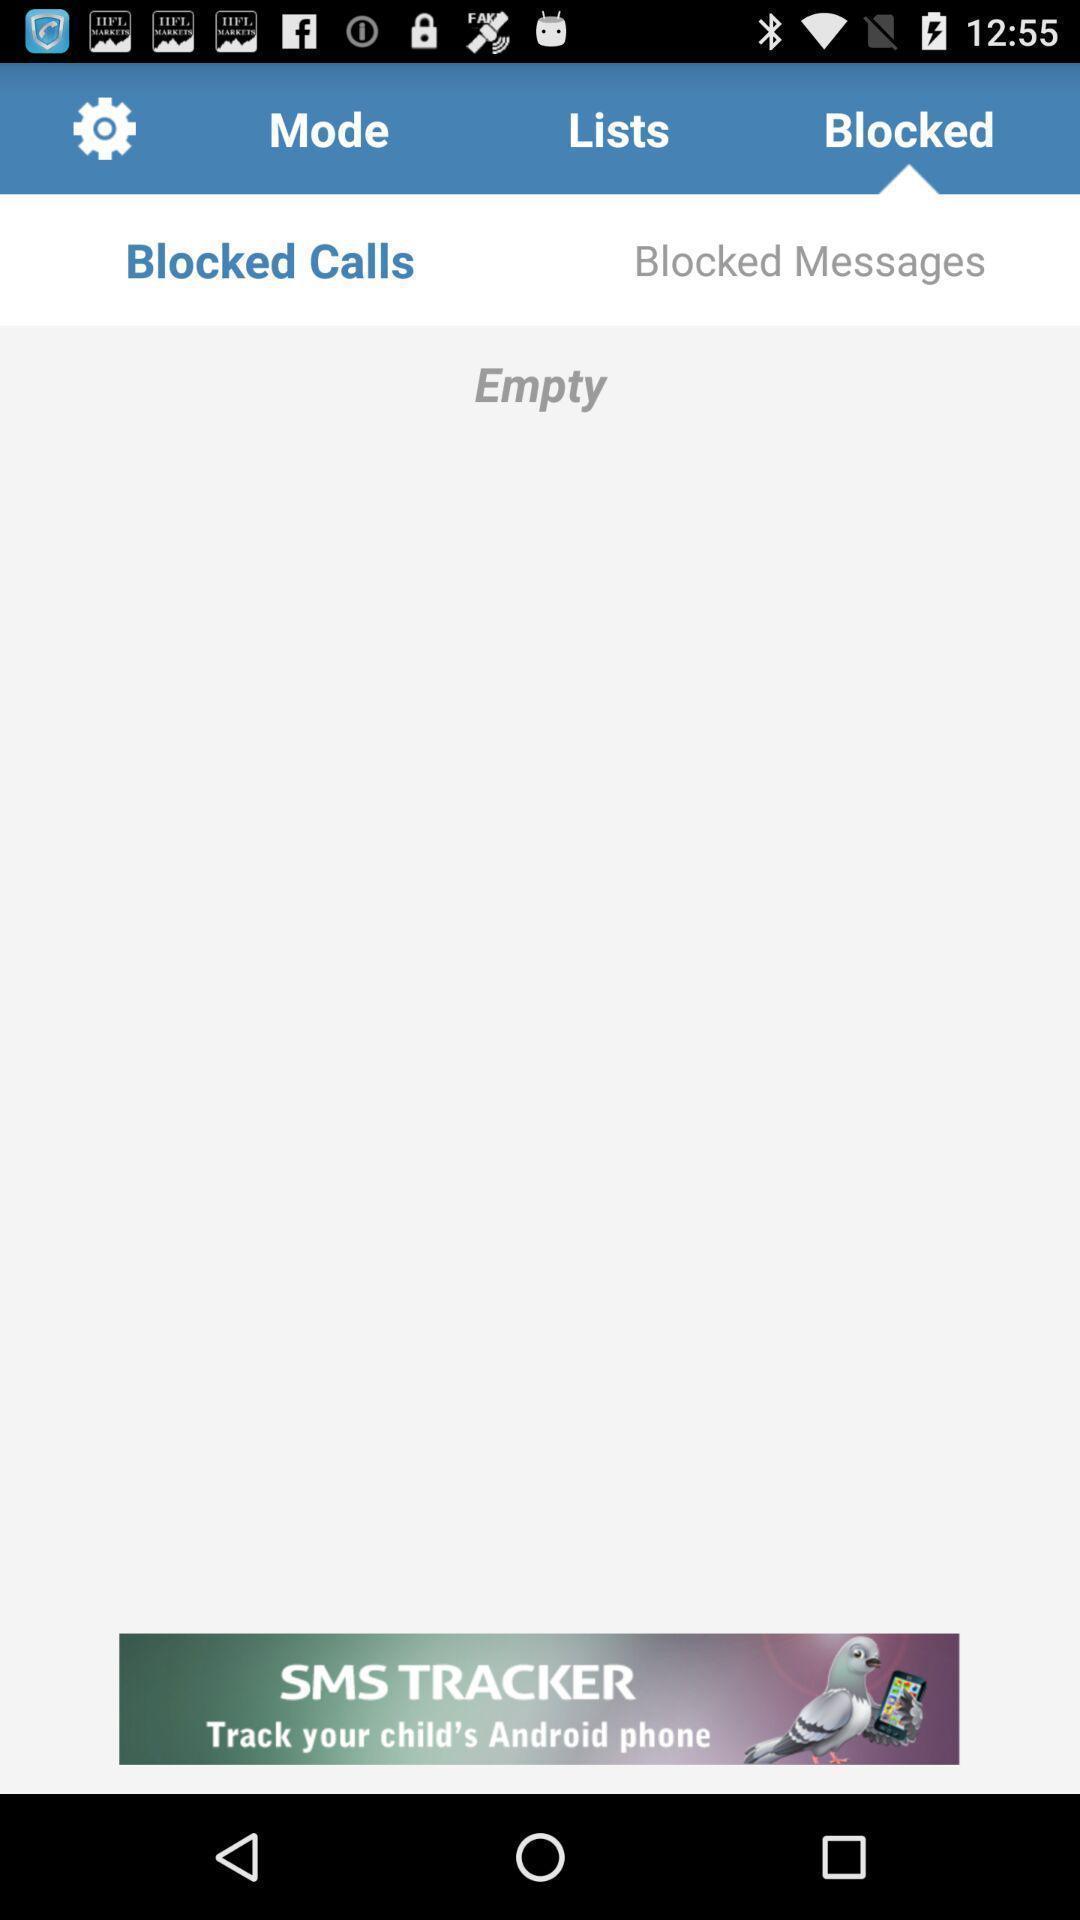Give me a narrative description of this picture. Screen displaying blocked messages page. 